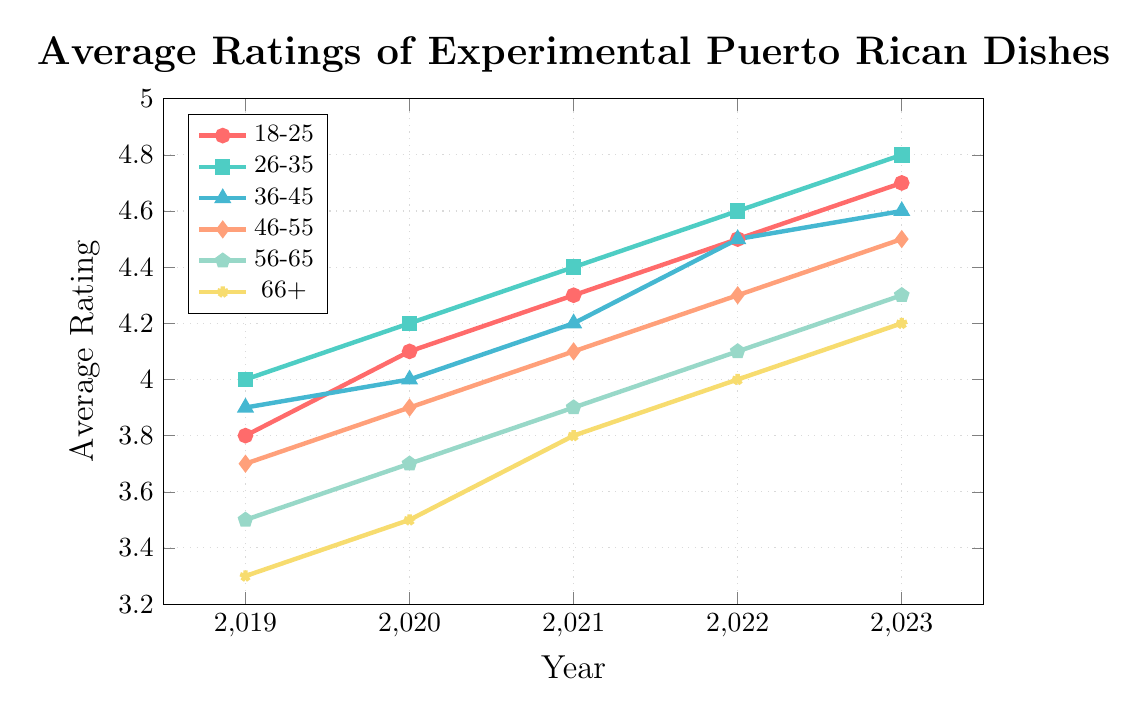Which age group had the highest average rating in 2023? First, locate the year 2023 on the x-axis. Then, identify the points corresponding to each age group. The group with the highest y-coordinate value is 26-35.
Answer: 26-35 Which age group saw the greatest increase in their average ratings from 2019 to 2023? Calculate the difference between the values for 2023 and 2019 for each age group:
- 18-25: 4.7 - 3.8 = 0.9
- 26-35: 4.8 - 4.0 = 0.8
- 36-45: 4.6 - 3.9 = 0.7
- 46-55: 4.5 - 3.7 = 0.8
- 56-65: 4.3 - 3.5 = 0.8
- 66+: 4.2 - 3.3 = 0.9
The greatest increase is 0.9, and it is seen in groups 18-25 and 66+.
Answer: 18-25 and 66+ What was the average rating for the 36-45 age group in 2021? Locate the point corresponding to the 36-45 age group in the year 2021. The y-coordinate for this point is 4.2.
Answer: 4.2 Which two age groups had the closest average ratings in 2022? Compare the 2022 average ratings for each age group:
- 18-25: 4.5
- 26-35: 4.6
- 36-45: 4.5
- 46-55: 4.3
- 56-65: 4.1
- 66+: 4.0
The groups 18-25 and 36-45 both have a rating of 4.5.
Answer: 18-25 and 36-45 How much did the average rating for the age group 56-65 increase from 2020 to 2021? Locate the 56-65 group and the years 2020 and 2021, then subtract the 2020 rating from the 2021 rating: 3.9 - 3.7 = 0.2.
Answer: 0.2 Which age group had the lowest average rating in 2019, and what was the rating? Locate the points for each age group in the year 2019. The lowest point is at y = 3.3, which corresponds to the 66+ age group.
Answer: 66+, 3.3 